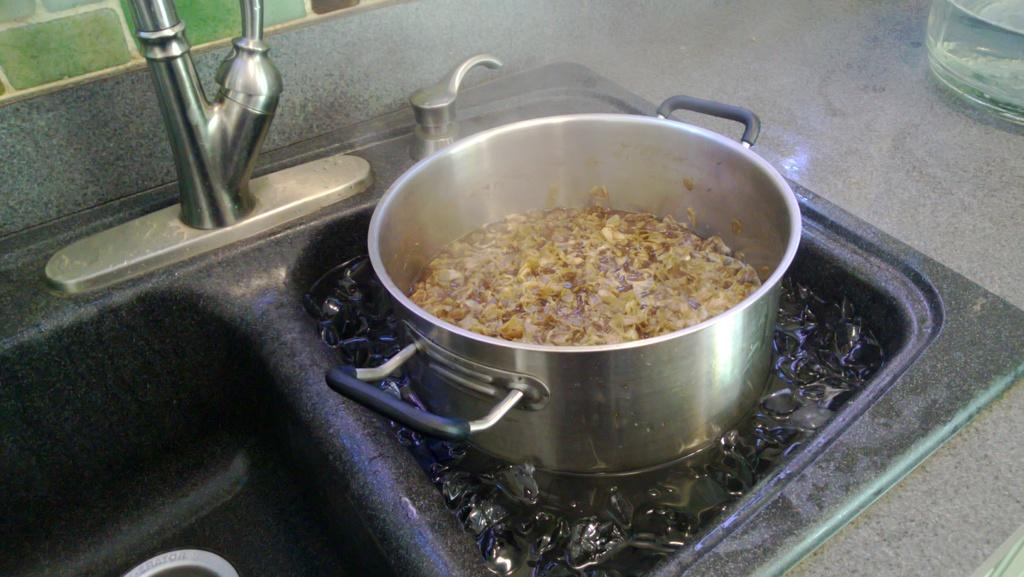What is the main object in the image? There is a vessel in the image. Where is the vessel located? The vessel is in a sink. What is inside the vessel? There are ice cubes in the vessel. What can be seen in the background of the image? There is a tap and a wall in the background of the image. What type of room might the image be taken in? The image appears to be taken in a kitchen. What type of skate is used to navigate the route in the image? There is no skate or route present in the image; it features a vessel with ice cubes in a sink in a kitchen. 